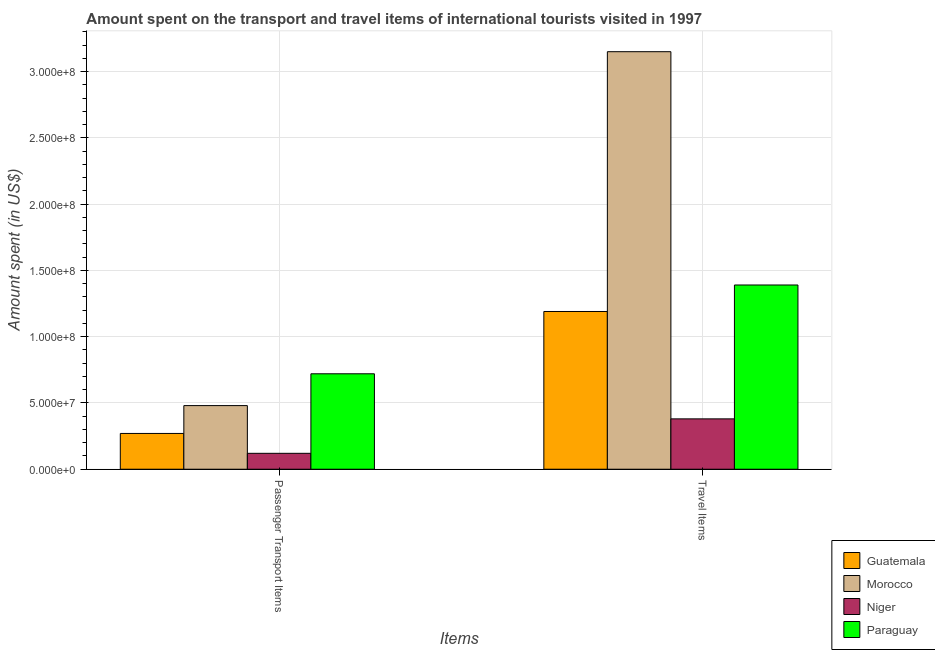How many different coloured bars are there?
Make the answer very short. 4. How many groups of bars are there?
Keep it short and to the point. 2. Are the number of bars per tick equal to the number of legend labels?
Give a very brief answer. Yes. Are the number of bars on each tick of the X-axis equal?
Give a very brief answer. Yes. How many bars are there on the 2nd tick from the left?
Give a very brief answer. 4. What is the label of the 1st group of bars from the left?
Offer a very short reply. Passenger Transport Items. What is the amount spent in travel items in Guatemala?
Your answer should be compact. 1.19e+08. Across all countries, what is the maximum amount spent on passenger transport items?
Make the answer very short. 7.20e+07. Across all countries, what is the minimum amount spent on passenger transport items?
Your answer should be very brief. 1.20e+07. In which country was the amount spent in travel items maximum?
Your response must be concise. Morocco. In which country was the amount spent on passenger transport items minimum?
Your answer should be very brief. Niger. What is the total amount spent in travel items in the graph?
Your answer should be compact. 6.11e+08. What is the difference between the amount spent on passenger transport items in Guatemala and that in Morocco?
Provide a short and direct response. -2.10e+07. What is the difference between the amount spent on passenger transport items in Niger and the amount spent in travel items in Morocco?
Your response must be concise. -3.03e+08. What is the average amount spent on passenger transport items per country?
Provide a short and direct response. 3.98e+07. What is the difference between the amount spent in travel items and amount spent on passenger transport items in Morocco?
Offer a terse response. 2.67e+08. In how many countries, is the amount spent in travel items greater than 80000000 US$?
Your answer should be very brief. 3. What is the ratio of the amount spent on passenger transport items in Paraguay to that in Morocco?
Keep it short and to the point. 1.5. In how many countries, is the amount spent on passenger transport items greater than the average amount spent on passenger transport items taken over all countries?
Offer a terse response. 2. What does the 4th bar from the left in Travel Items represents?
Ensure brevity in your answer.  Paraguay. What does the 1st bar from the right in Travel Items represents?
Offer a very short reply. Paraguay. Are all the bars in the graph horizontal?
Offer a very short reply. No. How many countries are there in the graph?
Your answer should be compact. 4. Does the graph contain any zero values?
Your answer should be compact. No. Does the graph contain grids?
Keep it short and to the point. Yes. How many legend labels are there?
Your answer should be compact. 4. How are the legend labels stacked?
Give a very brief answer. Vertical. What is the title of the graph?
Ensure brevity in your answer.  Amount spent on the transport and travel items of international tourists visited in 1997. What is the label or title of the X-axis?
Ensure brevity in your answer.  Items. What is the label or title of the Y-axis?
Keep it short and to the point. Amount spent (in US$). What is the Amount spent (in US$) of Guatemala in Passenger Transport Items?
Your response must be concise. 2.70e+07. What is the Amount spent (in US$) of Morocco in Passenger Transport Items?
Your response must be concise. 4.80e+07. What is the Amount spent (in US$) in Paraguay in Passenger Transport Items?
Offer a terse response. 7.20e+07. What is the Amount spent (in US$) in Guatemala in Travel Items?
Give a very brief answer. 1.19e+08. What is the Amount spent (in US$) in Morocco in Travel Items?
Keep it short and to the point. 3.15e+08. What is the Amount spent (in US$) of Niger in Travel Items?
Keep it short and to the point. 3.80e+07. What is the Amount spent (in US$) in Paraguay in Travel Items?
Your answer should be very brief. 1.39e+08. Across all Items, what is the maximum Amount spent (in US$) of Guatemala?
Make the answer very short. 1.19e+08. Across all Items, what is the maximum Amount spent (in US$) in Morocco?
Provide a succinct answer. 3.15e+08. Across all Items, what is the maximum Amount spent (in US$) in Niger?
Provide a succinct answer. 3.80e+07. Across all Items, what is the maximum Amount spent (in US$) of Paraguay?
Provide a succinct answer. 1.39e+08. Across all Items, what is the minimum Amount spent (in US$) of Guatemala?
Ensure brevity in your answer.  2.70e+07. Across all Items, what is the minimum Amount spent (in US$) in Morocco?
Provide a succinct answer. 4.80e+07. Across all Items, what is the minimum Amount spent (in US$) in Paraguay?
Ensure brevity in your answer.  7.20e+07. What is the total Amount spent (in US$) in Guatemala in the graph?
Provide a succinct answer. 1.46e+08. What is the total Amount spent (in US$) of Morocco in the graph?
Your answer should be compact. 3.63e+08. What is the total Amount spent (in US$) in Paraguay in the graph?
Keep it short and to the point. 2.11e+08. What is the difference between the Amount spent (in US$) of Guatemala in Passenger Transport Items and that in Travel Items?
Make the answer very short. -9.20e+07. What is the difference between the Amount spent (in US$) in Morocco in Passenger Transport Items and that in Travel Items?
Provide a short and direct response. -2.67e+08. What is the difference between the Amount spent (in US$) of Niger in Passenger Transport Items and that in Travel Items?
Offer a very short reply. -2.60e+07. What is the difference between the Amount spent (in US$) of Paraguay in Passenger Transport Items and that in Travel Items?
Provide a short and direct response. -6.70e+07. What is the difference between the Amount spent (in US$) in Guatemala in Passenger Transport Items and the Amount spent (in US$) in Morocco in Travel Items?
Your answer should be very brief. -2.88e+08. What is the difference between the Amount spent (in US$) in Guatemala in Passenger Transport Items and the Amount spent (in US$) in Niger in Travel Items?
Ensure brevity in your answer.  -1.10e+07. What is the difference between the Amount spent (in US$) in Guatemala in Passenger Transport Items and the Amount spent (in US$) in Paraguay in Travel Items?
Give a very brief answer. -1.12e+08. What is the difference between the Amount spent (in US$) of Morocco in Passenger Transport Items and the Amount spent (in US$) of Paraguay in Travel Items?
Offer a very short reply. -9.10e+07. What is the difference between the Amount spent (in US$) of Niger in Passenger Transport Items and the Amount spent (in US$) of Paraguay in Travel Items?
Provide a succinct answer. -1.27e+08. What is the average Amount spent (in US$) of Guatemala per Items?
Give a very brief answer. 7.30e+07. What is the average Amount spent (in US$) of Morocco per Items?
Provide a short and direct response. 1.82e+08. What is the average Amount spent (in US$) in Niger per Items?
Provide a succinct answer. 2.50e+07. What is the average Amount spent (in US$) in Paraguay per Items?
Make the answer very short. 1.06e+08. What is the difference between the Amount spent (in US$) of Guatemala and Amount spent (in US$) of Morocco in Passenger Transport Items?
Your response must be concise. -2.10e+07. What is the difference between the Amount spent (in US$) in Guatemala and Amount spent (in US$) in Niger in Passenger Transport Items?
Make the answer very short. 1.50e+07. What is the difference between the Amount spent (in US$) in Guatemala and Amount spent (in US$) in Paraguay in Passenger Transport Items?
Offer a very short reply. -4.50e+07. What is the difference between the Amount spent (in US$) of Morocco and Amount spent (in US$) of Niger in Passenger Transport Items?
Offer a terse response. 3.60e+07. What is the difference between the Amount spent (in US$) in Morocco and Amount spent (in US$) in Paraguay in Passenger Transport Items?
Make the answer very short. -2.40e+07. What is the difference between the Amount spent (in US$) in Niger and Amount spent (in US$) in Paraguay in Passenger Transport Items?
Give a very brief answer. -6.00e+07. What is the difference between the Amount spent (in US$) in Guatemala and Amount spent (in US$) in Morocco in Travel Items?
Give a very brief answer. -1.96e+08. What is the difference between the Amount spent (in US$) in Guatemala and Amount spent (in US$) in Niger in Travel Items?
Give a very brief answer. 8.10e+07. What is the difference between the Amount spent (in US$) of Guatemala and Amount spent (in US$) of Paraguay in Travel Items?
Your answer should be very brief. -2.00e+07. What is the difference between the Amount spent (in US$) in Morocco and Amount spent (in US$) in Niger in Travel Items?
Provide a short and direct response. 2.77e+08. What is the difference between the Amount spent (in US$) of Morocco and Amount spent (in US$) of Paraguay in Travel Items?
Make the answer very short. 1.76e+08. What is the difference between the Amount spent (in US$) of Niger and Amount spent (in US$) of Paraguay in Travel Items?
Your answer should be compact. -1.01e+08. What is the ratio of the Amount spent (in US$) of Guatemala in Passenger Transport Items to that in Travel Items?
Your response must be concise. 0.23. What is the ratio of the Amount spent (in US$) in Morocco in Passenger Transport Items to that in Travel Items?
Offer a very short reply. 0.15. What is the ratio of the Amount spent (in US$) in Niger in Passenger Transport Items to that in Travel Items?
Offer a terse response. 0.32. What is the ratio of the Amount spent (in US$) in Paraguay in Passenger Transport Items to that in Travel Items?
Provide a short and direct response. 0.52. What is the difference between the highest and the second highest Amount spent (in US$) of Guatemala?
Provide a succinct answer. 9.20e+07. What is the difference between the highest and the second highest Amount spent (in US$) in Morocco?
Make the answer very short. 2.67e+08. What is the difference between the highest and the second highest Amount spent (in US$) of Niger?
Make the answer very short. 2.60e+07. What is the difference between the highest and the second highest Amount spent (in US$) in Paraguay?
Offer a very short reply. 6.70e+07. What is the difference between the highest and the lowest Amount spent (in US$) of Guatemala?
Provide a short and direct response. 9.20e+07. What is the difference between the highest and the lowest Amount spent (in US$) of Morocco?
Your answer should be compact. 2.67e+08. What is the difference between the highest and the lowest Amount spent (in US$) in Niger?
Make the answer very short. 2.60e+07. What is the difference between the highest and the lowest Amount spent (in US$) of Paraguay?
Give a very brief answer. 6.70e+07. 